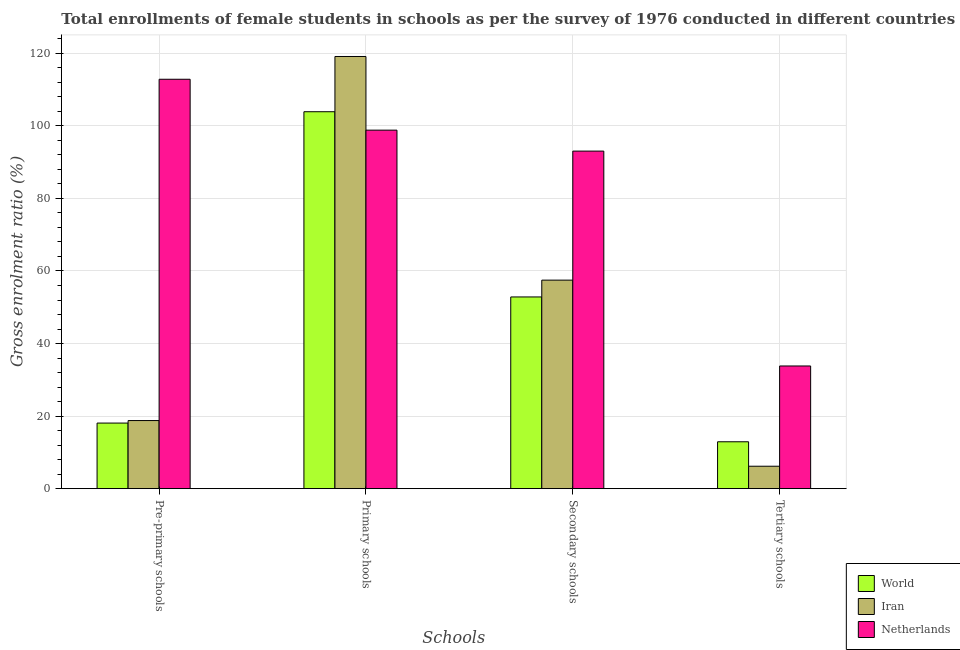Are the number of bars per tick equal to the number of legend labels?
Your answer should be compact. Yes. How many bars are there on the 2nd tick from the left?
Ensure brevity in your answer.  3. What is the label of the 4th group of bars from the left?
Provide a short and direct response. Tertiary schools. What is the gross enrolment ratio(female) in primary schools in World?
Give a very brief answer. 103.9. Across all countries, what is the maximum gross enrolment ratio(female) in pre-primary schools?
Your answer should be compact. 112.84. Across all countries, what is the minimum gross enrolment ratio(female) in primary schools?
Keep it short and to the point. 98.82. What is the total gross enrolment ratio(female) in secondary schools in the graph?
Your response must be concise. 203.37. What is the difference between the gross enrolment ratio(female) in tertiary schools in Iran and that in World?
Offer a very short reply. -6.74. What is the difference between the gross enrolment ratio(female) in secondary schools in Iran and the gross enrolment ratio(female) in primary schools in World?
Keep it short and to the point. -46.42. What is the average gross enrolment ratio(female) in pre-primary schools per country?
Your response must be concise. 49.9. What is the difference between the gross enrolment ratio(female) in primary schools and gross enrolment ratio(female) in tertiary schools in Iran?
Provide a short and direct response. 112.94. In how many countries, is the gross enrolment ratio(female) in tertiary schools greater than 104 %?
Keep it short and to the point. 0. What is the ratio of the gross enrolment ratio(female) in pre-primary schools in World to that in Netherlands?
Make the answer very short. 0.16. What is the difference between the highest and the second highest gross enrolment ratio(female) in pre-primary schools?
Keep it short and to the point. 94.07. What is the difference between the highest and the lowest gross enrolment ratio(female) in secondary schools?
Offer a terse response. 40.2. In how many countries, is the gross enrolment ratio(female) in secondary schools greater than the average gross enrolment ratio(female) in secondary schools taken over all countries?
Offer a very short reply. 1. Is the sum of the gross enrolment ratio(female) in secondary schools in Netherlands and Iran greater than the maximum gross enrolment ratio(female) in primary schools across all countries?
Keep it short and to the point. Yes. Is it the case that in every country, the sum of the gross enrolment ratio(female) in pre-primary schools and gross enrolment ratio(female) in primary schools is greater than the sum of gross enrolment ratio(female) in tertiary schools and gross enrolment ratio(female) in secondary schools?
Provide a succinct answer. No. What does the 1st bar from the right in Tertiary schools represents?
Offer a terse response. Netherlands. Are all the bars in the graph horizontal?
Make the answer very short. No. Does the graph contain any zero values?
Your answer should be compact. No. How many legend labels are there?
Your answer should be compact. 3. What is the title of the graph?
Provide a succinct answer. Total enrollments of female students in schools as per the survey of 1976 conducted in different countries. Does "Turkey" appear as one of the legend labels in the graph?
Ensure brevity in your answer.  No. What is the label or title of the X-axis?
Your answer should be compact. Schools. What is the label or title of the Y-axis?
Offer a very short reply. Gross enrolment ratio (%). What is the Gross enrolment ratio (%) in World in Pre-primary schools?
Make the answer very short. 18.08. What is the Gross enrolment ratio (%) in Iran in Pre-primary schools?
Provide a short and direct response. 18.78. What is the Gross enrolment ratio (%) in Netherlands in Pre-primary schools?
Offer a terse response. 112.84. What is the Gross enrolment ratio (%) in World in Primary schools?
Offer a terse response. 103.9. What is the Gross enrolment ratio (%) of Iran in Primary schools?
Make the answer very short. 119.12. What is the Gross enrolment ratio (%) in Netherlands in Primary schools?
Your answer should be compact. 98.82. What is the Gross enrolment ratio (%) in World in Secondary schools?
Your response must be concise. 52.85. What is the Gross enrolment ratio (%) of Iran in Secondary schools?
Your response must be concise. 57.48. What is the Gross enrolment ratio (%) of Netherlands in Secondary schools?
Ensure brevity in your answer.  93.04. What is the Gross enrolment ratio (%) in World in Tertiary schools?
Provide a succinct answer. 12.93. What is the Gross enrolment ratio (%) of Iran in Tertiary schools?
Provide a succinct answer. 6.19. What is the Gross enrolment ratio (%) in Netherlands in Tertiary schools?
Keep it short and to the point. 33.82. Across all Schools, what is the maximum Gross enrolment ratio (%) of World?
Keep it short and to the point. 103.9. Across all Schools, what is the maximum Gross enrolment ratio (%) in Iran?
Make the answer very short. 119.12. Across all Schools, what is the maximum Gross enrolment ratio (%) in Netherlands?
Your answer should be compact. 112.84. Across all Schools, what is the minimum Gross enrolment ratio (%) of World?
Your answer should be very brief. 12.93. Across all Schools, what is the minimum Gross enrolment ratio (%) of Iran?
Offer a terse response. 6.19. Across all Schools, what is the minimum Gross enrolment ratio (%) in Netherlands?
Your answer should be very brief. 33.82. What is the total Gross enrolment ratio (%) in World in the graph?
Your answer should be compact. 187.76. What is the total Gross enrolment ratio (%) in Iran in the graph?
Ensure brevity in your answer.  201.56. What is the total Gross enrolment ratio (%) of Netherlands in the graph?
Offer a very short reply. 338.53. What is the difference between the Gross enrolment ratio (%) in World in Pre-primary schools and that in Primary schools?
Offer a very short reply. -85.81. What is the difference between the Gross enrolment ratio (%) in Iran in Pre-primary schools and that in Primary schools?
Give a very brief answer. -100.35. What is the difference between the Gross enrolment ratio (%) in Netherlands in Pre-primary schools and that in Primary schools?
Provide a succinct answer. 14.03. What is the difference between the Gross enrolment ratio (%) of World in Pre-primary schools and that in Secondary schools?
Ensure brevity in your answer.  -34.76. What is the difference between the Gross enrolment ratio (%) in Iran in Pre-primary schools and that in Secondary schools?
Offer a very short reply. -38.7. What is the difference between the Gross enrolment ratio (%) of Netherlands in Pre-primary schools and that in Secondary schools?
Your response must be concise. 19.8. What is the difference between the Gross enrolment ratio (%) in World in Pre-primary schools and that in Tertiary schools?
Your response must be concise. 5.16. What is the difference between the Gross enrolment ratio (%) of Iran in Pre-primary schools and that in Tertiary schools?
Ensure brevity in your answer.  12.59. What is the difference between the Gross enrolment ratio (%) of Netherlands in Pre-primary schools and that in Tertiary schools?
Offer a terse response. 79.02. What is the difference between the Gross enrolment ratio (%) in World in Primary schools and that in Secondary schools?
Provide a short and direct response. 51.05. What is the difference between the Gross enrolment ratio (%) in Iran in Primary schools and that in Secondary schools?
Keep it short and to the point. 61.64. What is the difference between the Gross enrolment ratio (%) in Netherlands in Primary schools and that in Secondary schools?
Your response must be concise. 5.77. What is the difference between the Gross enrolment ratio (%) of World in Primary schools and that in Tertiary schools?
Ensure brevity in your answer.  90.97. What is the difference between the Gross enrolment ratio (%) of Iran in Primary schools and that in Tertiary schools?
Your response must be concise. 112.94. What is the difference between the Gross enrolment ratio (%) in Netherlands in Primary schools and that in Tertiary schools?
Provide a short and direct response. 65. What is the difference between the Gross enrolment ratio (%) in World in Secondary schools and that in Tertiary schools?
Offer a terse response. 39.92. What is the difference between the Gross enrolment ratio (%) of Iran in Secondary schools and that in Tertiary schools?
Ensure brevity in your answer.  51.29. What is the difference between the Gross enrolment ratio (%) in Netherlands in Secondary schools and that in Tertiary schools?
Offer a very short reply. 59.22. What is the difference between the Gross enrolment ratio (%) of World in Pre-primary schools and the Gross enrolment ratio (%) of Iran in Primary schools?
Your answer should be compact. -101.04. What is the difference between the Gross enrolment ratio (%) in World in Pre-primary schools and the Gross enrolment ratio (%) in Netherlands in Primary schools?
Offer a very short reply. -80.73. What is the difference between the Gross enrolment ratio (%) of Iran in Pre-primary schools and the Gross enrolment ratio (%) of Netherlands in Primary schools?
Provide a succinct answer. -80.04. What is the difference between the Gross enrolment ratio (%) in World in Pre-primary schools and the Gross enrolment ratio (%) in Iran in Secondary schools?
Your answer should be compact. -39.39. What is the difference between the Gross enrolment ratio (%) of World in Pre-primary schools and the Gross enrolment ratio (%) of Netherlands in Secondary schools?
Your answer should be very brief. -74.96. What is the difference between the Gross enrolment ratio (%) in Iran in Pre-primary schools and the Gross enrolment ratio (%) in Netherlands in Secondary schools?
Ensure brevity in your answer.  -74.27. What is the difference between the Gross enrolment ratio (%) of World in Pre-primary schools and the Gross enrolment ratio (%) of Iran in Tertiary schools?
Offer a terse response. 11.9. What is the difference between the Gross enrolment ratio (%) in World in Pre-primary schools and the Gross enrolment ratio (%) in Netherlands in Tertiary schools?
Offer a terse response. -15.74. What is the difference between the Gross enrolment ratio (%) in Iran in Pre-primary schools and the Gross enrolment ratio (%) in Netherlands in Tertiary schools?
Keep it short and to the point. -15.04. What is the difference between the Gross enrolment ratio (%) of World in Primary schools and the Gross enrolment ratio (%) of Iran in Secondary schools?
Your response must be concise. 46.42. What is the difference between the Gross enrolment ratio (%) in World in Primary schools and the Gross enrolment ratio (%) in Netherlands in Secondary schools?
Offer a terse response. 10.85. What is the difference between the Gross enrolment ratio (%) in Iran in Primary schools and the Gross enrolment ratio (%) in Netherlands in Secondary schools?
Give a very brief answer. 26.08. What is the difference between the Gross enrolment ratio (%) of World in Primary schools and the Gross enrolment ratio (%) of Iran in Tertiary schools?
Ensure brevity in your answer.  97.71. What is the difference between the Gross enrolment ratio (%) of World in Primary schools and the Gross enrolment ratio (%) of Netherlands in Tertiary schools?
Provide a succinct answer. 70.08. What is the difference between the Gross enrolment ratio (%) in Iran in Primary schools and the Gross enrolment ratio (%) in Netherlands in Tertiary schools?
Your answer should be very brief. 85.3. What is the difference between the Gross enrolment ratio (%) in World in Secondary schools and the Gross enrolment ratio (%) in Iran in Tertiary schools?
Provide a short and direct response. 46.66. What is the difference between the Gross enrolment ratio (%) of World in Secondary schools and the Gross enrolment ratio (%) of Netherlands in Tertiary schools?
Provide a short and direct response. 19.03. What is the difference between the Gross enrolment ratio (%) of Iran in Secondary schools and the Gross enrolment ratio (%) of Netherlands in Tertiary schools?
Make the answer very short. 23.66. What is the average Gross enrolment ratio (%) in World per Schools?
Offer a very short reply. 46.94. What is the average Gross enrolment ratio (%) in Iran per Schools?
Provide a succinct answer. 50.39. What is the average Gross enrolment ratio (%) of Netherlands per Schools?
Provide a succinct answer. 84.63. What is the difference between the Gross enrolment ratio (%) of World and Gross enrolment ratio (%) of Iran in Pre-primary schools?
Your answer should be compact. -0.69. What is the difference between the Gross enrolment ratio (%) of World and Gross enrolment ratio (%) of Netherlands in Pre-primary schools?
Keep it short and to the point. -94.76. What is the difference between the Gross enrolment ratio (%) of Iran and Gross enrolment ratio (%) of Netherlands in Pre-primary schools?
Keep it short and to the point. -94.07. What is the difference between the Gross enrolment ratio (%) of World and Gross enrolment ratio (%) of Iran in Primary schools?
Provide a succinct answer. -15.23. What is the difference between the Gross enrolment ratio (%) of World and Gross enrolment ratio (%) of Netherlands in Primary schools?
Your answer should be very brief. 5.08. What is the difference between the Gross enrolment ratio (%) in Iran and Gross enrolment ratio (%) in Netherlands in Primary schools?
Ensure brevity in your answer.  20.3. What is the difference between the Gross enrolment ratio (%) in World and Gross enrolment ratio (%) in Iran in Secondary schools?
Ensure brevity in your answer.  -4.63. What is the difference between the Gross enrolment ratio (%) in World and Gross enrolment ratio (%) in Netherlands in Secondary schools?
Keep it short and to the point. -40.2. What is the difference between the Gross enrolment ratio (%) of Iran and Gross enrolment ratio (%) of Netherlands in Secondary schools?
Ensure brevity in your answer.  -35.57. What is the difference between the Gross enrolment ratio (%) of World and Gross enrolment ratio (%) of Iran in Tertiary schools?
Your answer should be compact. 6.74. What is the difference between the Gross enrolment ratio (%) in World and Gross enrolment ratio (%) in Netherlands in Tertiary schools?
Ensure brevity in your answer.  -20.89. What is the difference between the Gross enrolment ratio (%) in Iran and Gross enrolment ratio (%) in Netherlands in Tertiary schools?
Ensure brevity in your answer.  -27.63. What is the ratio of the Gross enrolment ratio (%) of World in Pre-primary schools to that in Primary schools?
Provide a short and direct response. 0.17. What is the ratio of the Gross enrolment ratio (%) of Iran in Pre-primary schools to that in Primary schools?
Give a very brief answer. 0.16. What is the ratio of the Gross enrolment ratio (%) of Netherlands in Pre-primary schools to that in Primary schools?
Your response must be concise. 1.14. What is the ratio of the Gross enrolment ratio (%) of World in Pre-primary schools to that in Secondary schools?
Offer a very short reply. 0.34. What is the ratio of the Gross enrolment ratio (%) of Iran in Pre-primary schools to that in Secondary schools?
Your response must be concise. 0.33. What is the ratio of the Gross enrolment ratio (%) in Netherlands in Pre-primary schools to that in Secondary schools?
Offer a very short reply. 1.21. What is the ratio of the Gross enrolment ratio (%) in World in Pre-primary schools to that in Tertiary schools?
Ensure brevity in your answer.  1.4. What is the ratio of the Gross enrolment ratio (%) in Iran in Pre-primary schools to that in Tertiary schools?
Your answer should be compact. 3.03. What is the ratio of the Gross enrolment ratio (%) of Netherlands in Pre-primary schools to that in Tertiary schools?
Give a very brief answer. 3.34. What is the ratio of the Gross enrolment ratio (%) of World in Primary schools to that in Secondary schools?
Make the answer very short. 1.97. What is the ratio of the Gross enrolment ratio (%) in Iran in Primary schools to that in Secondary schools?
Make the answer very short. 2.07. What is the ratio of the Gross enrolment ratio (%) of Netherlands in Primary schools to that in Secondary schools?
Give a very brief answer. 1.06. What is the ratio of the Gross enrolment ratio (%) of World in Primary schools to that in Tertiary schools?
Give a very brief answer. 8.04. What is the ratio of the Gross enrolment ratio (%) of Iran in Primary schools to that in Tertiary schools?
Make the answer very short. 19.25. What is the ratio of the Gross enrolment ratio (%) in Netherlands in Primary schools to that in Tertiary schools?
Ensure brevity in your answer.  2.92. What is the ratio of the Gross enrolment ratio (%) in World in Secondary schools to that in Tertiary schools?
Ensure brevity in your answer.  4.09. What is the ratio of the Gross enrolment ratio (%) of Iran in Secondary schools to that in Tertiary schools?
Give a very brief answer. 9.29. What is the ratio of the Gross enrolment ratio (%) of Netherlands in Secondary schools to that in Tertiary schools?
Give a very brief answer. 2.75. What is the difference between the highest and the second highest Gross enrolment ratio (%) in World?
Give a very brief answer. 51.05. What is the difference between the highest and the second highest Gross enrolment ratio (%) in Iran?
Your answer should be compact. 61.64. What is the difference between the highest and the second highest Gross enrolment ratio (%) in Netherlands?
Your answer should be compact. 14.03. What is the difference between the highest and the lowest Gross enrolment ratio (%) of World?
Your response must be concise. 90.97. What is the difference between the highest and the lowest Gross enrolment ratio (%) in Iran?
Provide a short and direct response. 112.94. What is the difference between the highest and the lowest Gross enrolment ratio (%) in Netherlands?
Your answer should be compact. 79.02. 